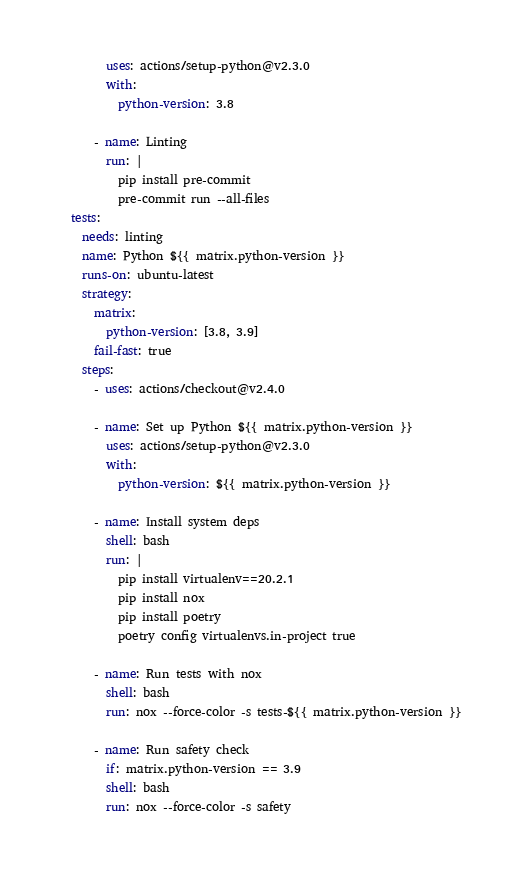<code> <loc_0><loc_0><loc_500><loc_500><_YAML_>        uses: actions/setup-python@v2.3.0
        with:
          python-version: 3.8

      - name: Linting
        run: |
          pip install pre-commit
          pre-commit run --all-files
  tests:
    needs: linting
    name: Python ${{ matrix.python-version }}
    runs-on: ubuntu-latest
    strategy:
      matrix:
        python-version: [3.8, 3.9]
      fail-fast: true
    steps:
      - uses: actions/checkout@v2.4.0

      - name: Set up Python ${{ matrix.python-version }}
        uses: actions/setup-python@v2.3.0
        with:
          python-version: ${{ matrix.python-version }}

      - name: Install system deps
        shell: bash
        run: |
          pip install virtualenv==20.2.1
          pip install nox
          pip install poetry
          poetry config virtualenvs.in-project true

      - name: Run tests with nox
        shell: bash
        run: nox --force-color -s tests-${{ matrix.python-version }}

      - name: Run safety check
        if: matrix.python-version == 3.9
        shell: bash
        run: nox --force-color -s safety
</code> 